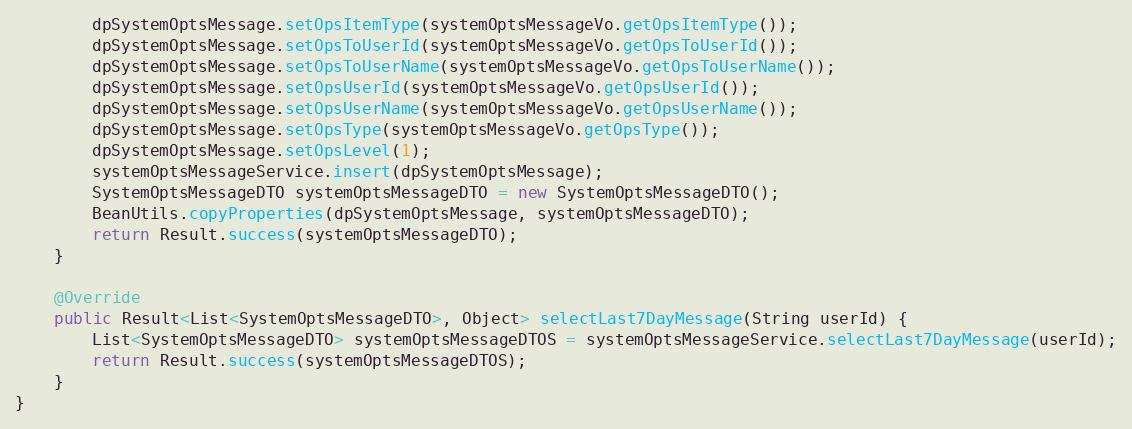Convert code to text. <code><loc_0><loc_0><loc_500><loc_500><_Java_>        dpSystemOptsMessage.setOpsItemType(systemOptsMessageVo.getOpsItemType());
        dpSystemOptsMessage.setOpsToUserId(systemOptsMessageVo.getOpsToUserId());
        dpSystemOptsMessage.setOpsToUserName(systemOptsMessageVo.getOpsToUserName());
        dpSystemOptsMessage.setOpsUserId(systemOptsMessageVo.getOpsUserId());
        dpSystemOptsMessage.setOpsUserName(systemOptsMessageVo.getOpsUserName());
        dpSystemOptsMessage.setOpsType(systemOptsMessageVo.getOpsType());
        dpSystemOptsMessage.setOpsLevel(1);
        systemOptsMessageService.insert(dpSystemOptsMessage);
        SystemOptsMessageDTO systemOptsMessageDTO = new SystemOptsMessageDTO();
        BeanUtils.copyProperties(dpSystemOptsMessage, systemOptsMessageDTO);
        return Result.success(systemOptsMessageDTO);
    }

    @Override
    public Result<List<SystemOptsMessageDTO>, Object> selectLast7DayMessage(String userId) {
        List<SystemOptsMessageDTO> systemOptsMessageDTOS = systemOptsMessageService.selectLast7DayMessage(userId);
        return Result.success(systemOptsMessageDTOS);
    }
}
</code> 